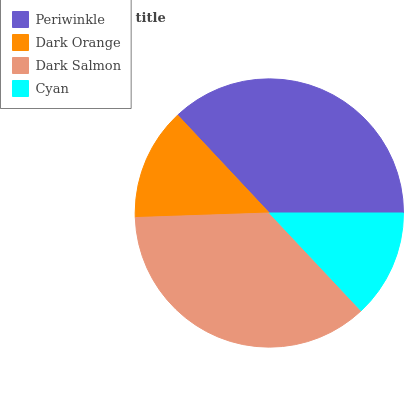Is Cyan the minimum?
Answer yes or no. Yes. Is Periwinkle the maximum?
Answer yes or no. Yes. Is Dark Orange the minimum?
Answer yes or no. No. Is Dark Orange the maximum?
Answer yes or no. No. Is Periwinkle greater than Dark Orange?
Answer yes or no. Yes. Is Dark Orange less than Periwinkle?
Answer yes or no. Yes. Is Dark Orange greater than Periwinkle?
Answer yes or no. No. Is Periwinkle less than Dark Orange?
Answer yes or no. No. Is Dark Salmon the high median?
Answer yes or no. Yes. Is Dark Orange the low median?
Answer yes or no. Yes. Is Dark Orange the high median?
Answer yes or no. No. Is Periwinkle the low median?
Answer yes or no. No. 